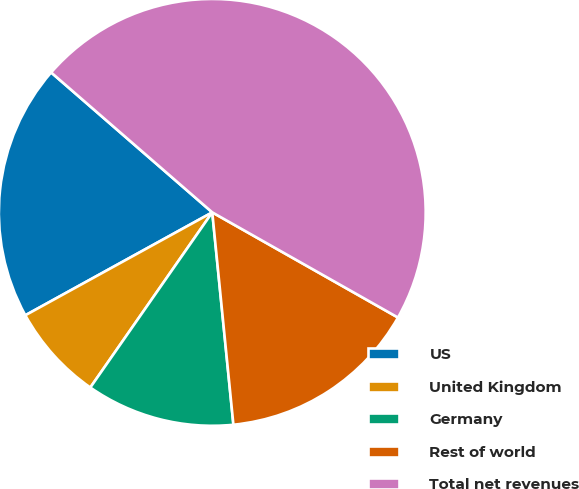Convert chart to OTSL. <chart><loc_0><loc_0><loc_500><loc_500><pie_chart><fcel>US<fcel>United Kingdom<fcel>Germany<fcel>Rest of world<fcel>Total net revenues<nl><fcel>19.39%<fcel>7.31%<fcel>11.26%<fcel>15.22%<fcel>46.82%<nl></chart> 